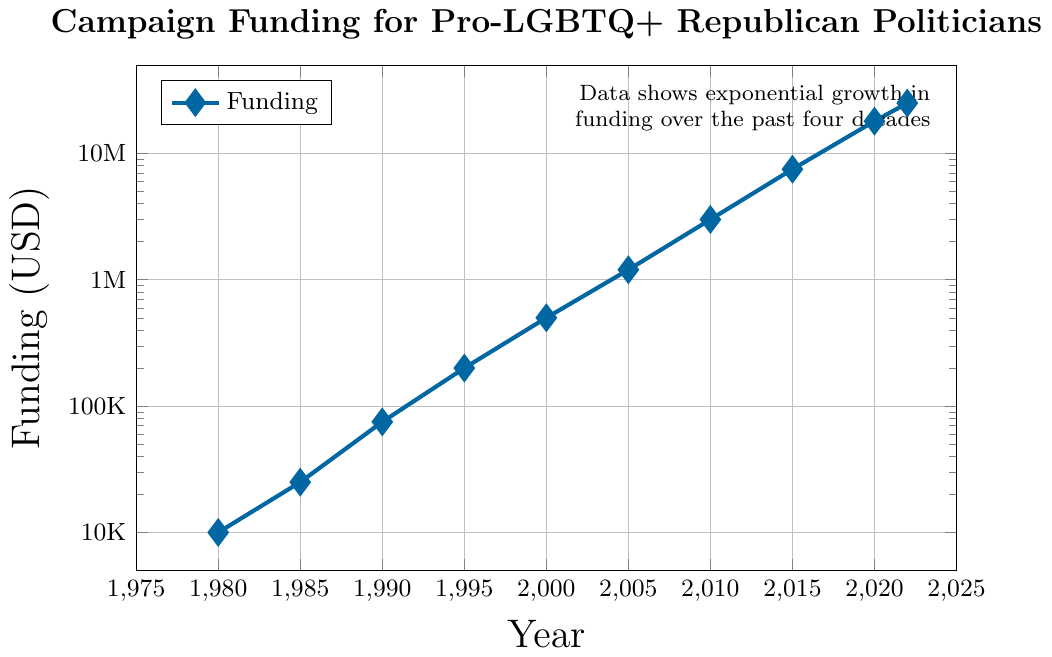What is the funding amount in 2000? The year 2000 corresponds to a point marked on the chart. Following the x-axis to 2000 and the y-axis to the corresponding point reveals the funding amount.
Answer: $500,000 By how much did the funding increase between 1995 and 2000? To find the increase, take the funding amount in 2000 and subtract the amount in 1995. From the chart, funding in 1995 is $200,000 and in 2000 it's $500,000. The increase is $500,000 - $200,000.
Answer: $300,000 Which year experienced the highest funding according to the chart? The chart shows the progression of funding across multiple years. The point with the highest y-axis value corresponds to the highest funding, which is in 2022.
Answer: 2022 Compare the funding amount in 1990 and 2010. Which year had higher funding and by how much? Locate the points for 1990 and 2010 on the chart. Funding in 1990 is $75,000 and in 2010 is $3,000,000. Subtract the smaller amount from the larger to find the difference.
Answer: 2010 by $2,925,000 What trend is observed in the campaign funding over the years? The chart shows an upward movement in the funding amounts with time, and as it’s represented on a log scale, it signifies an exponential growth pattern.
Answer: Exponential growth Visualize the point at 1985: What is the significance of its position relative to the 1980 and 1990 points? The point at 1985 is positioned between 1980 and 1990 on the x-axis, with its y-axis value higher than 1980 but lower than 1990, indicating an increase in funding from 1980 but lesser than the funding in 1990.
Answer: Funding increased from 1980 but is less than 1990 What funding level does the data annotation suggest has increased over the past four decades? The annotation on the chart mentions “exponential growth in funding,” indicating a significant increment over the past 40 years, reaching the highest funding level by 2022.
Answer: Highest level by 2022 What is the approximate factor by which campaign funding increased from 1985 to 2005? Funding in 1985 is $25,000, and in 2005 is $1,200,000. The factor can be calculated by dividing the latter by the former: $1,200,000 / $25,000.
Answer: 48 times Which color was used to represent the campaign funding data points, and what could it signify? The chart uses a blue diamond shape to represent the data points. Blue often symbolizes stability and trust, significant attributes for campaign funding.
Answer: Blue What's the rate of funding increase between 2015 and 2020 in percentage terms? Funding in 2015 is $7,500,000 and in 2020 is $18,000,000. The rate of increase is calculated as: ((18,000,000 - 7,500,000) / 7,500,000) * 100%.
Answer: 140% 